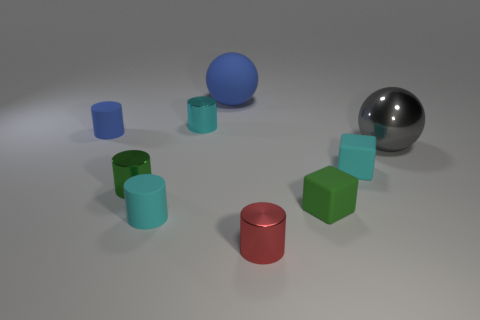Is the number of blue matte spheres right of the large gray sphere less than the number of yellow rubber cubes?
Offer a terse response. No. What number of metallic cylinders have the same size as the red metal object?
Offer a very short reply. 2. What is the shape of the small matte object that is the same color as the large matte sphere?
Keep it short and to the point. Cylinder. Does the small rubber cylinder that is in front of the green metallic thing have the same color as the tiny block that is behind the green shiny cylinder?
Provide a succinct answer. Yes. What number of red things are behind the big gray shiny thing?
Make the answer very short. 0. What is the size of the other thing that is the same color as the large matte object?
Your answer should be compact. Small. Is there another big object that has the same shape as the large matte object?
Provide a succinct answer. Yes. There is another rubber cylinder that is the same size as the blue matte cylinder; what color is it?
Make the answer very short. Cyan. Are there fewer cyan shiny objects that are right of the large shiny thing than shiny things left of the red cylinder?
Ensure brevity in your answer.  Yes. Is the size of the blue ball that is behind the blue cylinder the same as the gray metal thing?
Provide a short and direct response. Yes. 